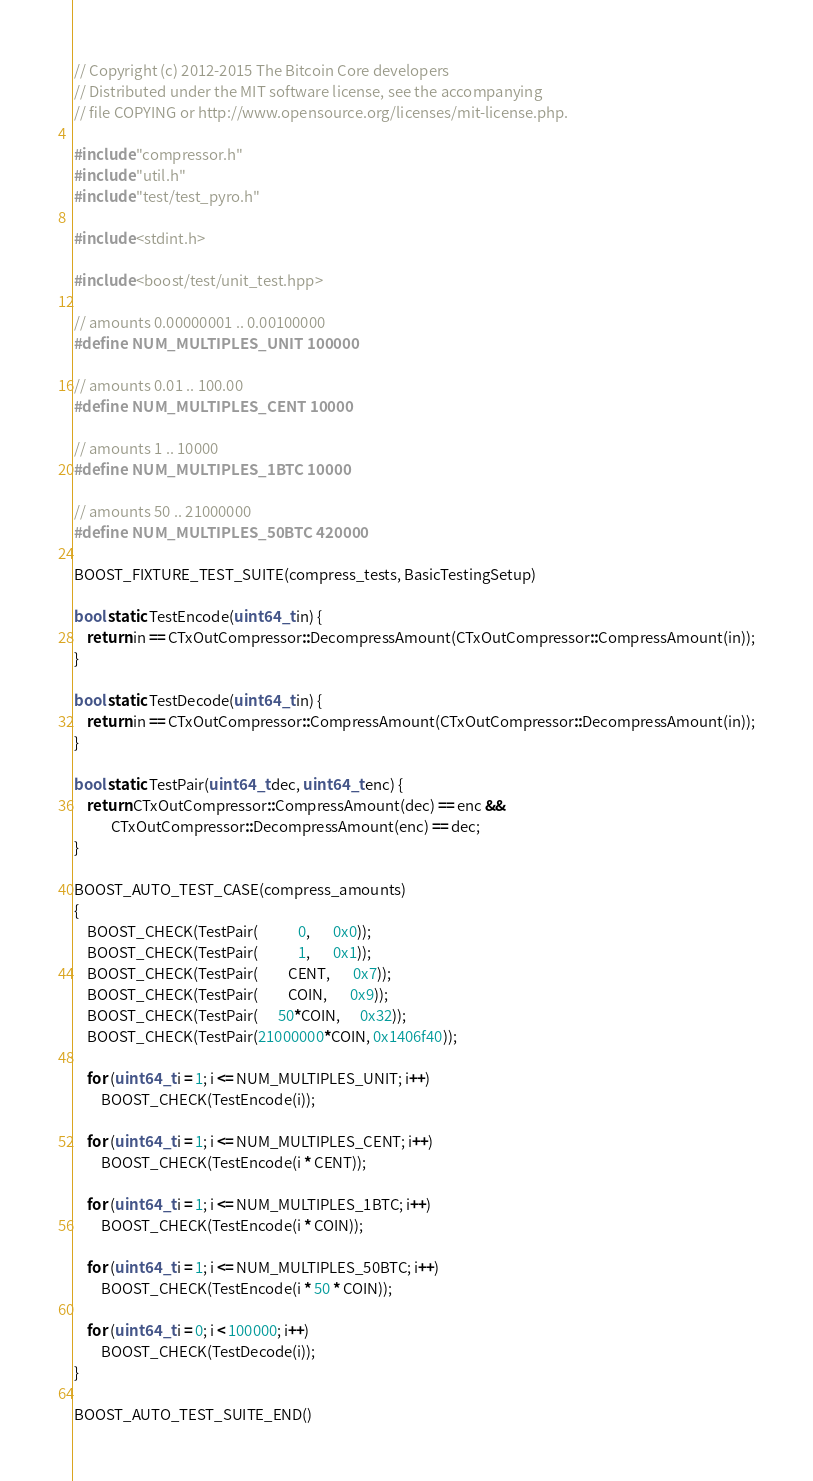Convert code to text. <code><loc_0><loc_0><loc_500><loc_500><_C++_>// Copyright (c) 2012-2015 The Bitcoin Core developers
// Distributed under the MIT software license, see the accompanying
// file COPYING or http://www.opensource.org/licenses/mit-license.php.

#include "compressor.h"
#include "util.h"
#include "test/test_pyro.h"

#include <stdint.h>

#include <boost/test/unit_test.hpp>

// amounts 0.00000001 .. 0.00100000
#define NUM_MULTIPLES_UNIT 100000

// amounts 0.01 .. 100.00
#define NUM_MULTIPLES_CENT 10000

// amounts 1 .. 10000
#define NUM_MULTIPLES_1BTC 10000

// amounts 50 .. 21000000
#define NUM_MULTIPLES_50BTC 420000

BOOST_FIXTURE_TEST_SUITE(compress_tests, BasicTestingSetup)

bool static TestEncode(uint64_t in) {
    return in == CTxOutCompressor::DecompressAmount(CTxOutCompressor::CompressAmount(in));
}

bool static TestDecode(uint64_t in) {
    return in == CTxOutCompressor::CompressAmount(CTxOutCompressor::DecompressAmount(in));
}

bool static TestPair(uint64_t dec, uint64_t enc) {
    return CTxOutCompressor::CompressAmount(dec) == enc &&
           CTxOutCompressor::DecompressAmount(enc) == dec;
}

BOOST_AUTO_TEST_CASE(compress_amounts)
{
    BOOST_CHECK(TestPair(            0,       0x0));
    BOOST_CHECK(TestPair(            1,       0x1));
    BOOST_CHECK(TestPair(         CENT,       0x7));
    BOOST_CHECK(TestPair(         COIN,       0x9));
    BOOST_CHECK(TestPair(      50*COIN,      0x32));
    BOOST_CHECK(TestPair(21000000*COIN, 0x1406f40));

    for (uint64_t i = 1; i <= NUM_MULTIPLES_UNIT; i++)
        BOOST_CHECK(TestEncode(i));

    for (uint64_t i = 1; i <= NUM_MULTIPLES_CENT; i++)
        BOOST_CHECK(TestEncode(i * CENT));

    for (uint64_t i = 1; i <= NUM_MULTIPLES_1BTC; i++)
        BOOST_CHECK(TestEncode(i * COIN));

    for (uint64_t i = 1; i <= NUM_MULTIPLES_50BTC; i++)
        BOOST_CHECK(TestEncode(i * 50 * COIN));

    for (uint64_t i = 0; i < 100000; i++)
        BOOST_CHECK(TestDecode(i));
}

BOOST_AUTO_TEST_SUITE_END()
</code> 